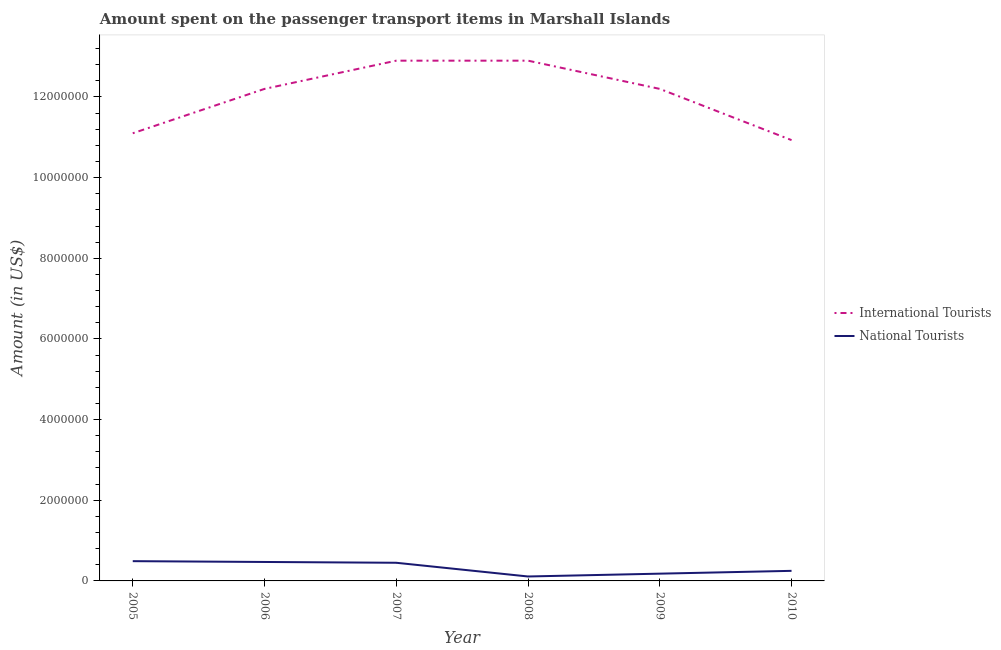How many different coloured lines are there?
Keep it short and to the point. 2. Does the line corresponding to amount spent on transport items of national tourists intersect with the line corresponding to amount spent on transport items of international tourists?
Ensure brevity in your answer.  No. Is the number of lines equal to the number of legend labels?
Provide a short and direct response. Yes. What is the amount spent on transport items of international tourists in 2005?
Your answer should be compact. 1.11e+07. Across all years, what is the maximum amount spent on transport items of national tourists?
Ensure brevity in your answer.  4.90e+05. Across all years, what is the minimum amount spent on transport items of national tourists?
Your answer should be compact. 1.10e+05. What is the total amount spent on transport items of national tourists in the graph?
Provide a succinct answer. 1.95e+06. What is the difference between the amount spent on transport items of international tourists in 2005 and that in 2006?
Your answer should be compact. -1.10e+06. What is the difference between the amount spent on transport items of international tourists in 2010 and the amount spent on transport items of national tourists in 2005?
Offer a very short reply. 1.04e+07. What is the average amount spent on transport items of international tourists per year?
Your response must be concise. 1.20e+07. In the year 2010, what is the difference between the amount spent on transport items of national tourists and amount spent on transport items of international tourists?
Make the answer very short. -1.07e+07. What is the ratio of the amount spent on transport items of international tourists in 2007 to that in 2008?
Provide a short and direct response. 1. Is the amount spent on transport items of international tourists in 2005 less than that in 2009?
Your answer should be compact. Yes. Is the difference between the amount spent on transport items of international tourists in 2006 and 2009 greater than the difference between the amount spent on transport items of national tourists in 2006 and 2009?
Offer a very short reply. No. What is the difference between the highest and the lowest amount spent on transport items of national tourists?
Make the answer very short. 3.80e+05. Is the sum of the amount spent on transport items of national tourists in 2006 and 2007 greater than the maximum amount spent on transport items of international tourists across all years?
Provide a succinct answer. No. Does the amount spent on transport items of international tourists monotonically increase over the years?
Your response must be concise. No. Is the amount spent on transport items of national tourists strictly less than the amount spent on transport items of international tourists over the years?
Make the answer very short. Yes. How many lines are there?
Provide a succinct answer. 2. How many years are there in the graph?
Offer a terse response. 6. Are the values on the major ticks of Y-axis written in scientific E-notation?
Your answer should be very brief. No. Does the graph contain grids?
Your answer should be very brief. No. Where does the legend appear in the graph?
Make the answer very short. Center right. What is the title of the graph?
Provide a short and direct response. Amount spent on the passenger transport items in Marshall Islands. Does "Taxes" appear as one of the legend labels in the graph?
Your response must be concise. No. What is the label or title of the Y-axis?
Your answer should be compact. Amount (in US$). What is the Amount (in US$) of International Tourists in 2005?
Your response must be concise. 1.11e+07. What is the Amount (in US$) in National Tourists in 2005?
Make the answer very short. 4.90e+05. What is the Amount (in US$) in International Tourists in 2006?
Offer a terse response. 1.22e+07. What is the Amount (in US$) in National Tourists in 2006?
Offer a very short reply. 4.70e+05. What is the Amount (in US$) of International Tourists in 2007?
Offer a very short reply. 1.29e+07. What is the Amount (in US$) in International Tourists in 2008?
Provide a succinct answer. 1.29e+07. What is the Amount (in US$) of National Tourists in 2008?
Provide a short and direct response. 1.10e+05. What is the Amount (in US$) in International Tourists in 2009?
Provide a succinct answer. 1.22e+07. What is the Amount (in US$) of International Tourists in 2010?
Offer a terse response. 1.09e+07. What is the Amount (in US$) in National Tourists in 2010?
Your answer should be very brief. 2.50e+05. Across all years, what is the maximum Amount (in US$) of International Tourists?
Offer a terse response. 1.29e+07. Across all years, what is the maximum Amount (in US$) of National Tourists?
Give a very brief answer. 4.90e+05. Across all years, what is the minimum Amount (in US$) of International Tourists?
Ensure brevity in your answer.  1.09e+07. Across all years, what is the minimum Amount (in US$) of National Tourists?
Your answer should be compact. 1.10e+05. What is the total Amount (in US$) in International Tourists in the graph?
Keep it short and to the point. 7.22e+07. What is the total Amount (in US$) in National Tourists in the graph?
Your answer should be very brief. 1.95e+06. What is the difference between the Amount (in US$) of International Tourists in 2005 and that in 2006?
Ensure brevity in your answer.  -1.10e+06. What is the difference between the Amount (in US$) of National Tourists in 2005 and that in 2006?
Ensure brevity in your answer.  2.00e+04. What is the difference between the Amount (in US$) of International Tourists in 2005 and that in 2007?
Offer a terse response. -1.80e+06. What is the difference between the Amount (in US$) of National Tourists in 2005 and that in 2007?
Your response must be concise. 4.00e+04. What is the difference between the Amount (in US$) of International Tourists in 2005 and that in 2008?
Give a very brief answer. -1.80e+06. What is the difference between the Amount (in US$) in National Tourists in 2005 and that in 2008?
Provide a succinct answer. 3.80e+05. What is the difference between the Amount (in US$) in International Tourists in 2005 and that in 2009?
Your answer should be compact. -1.10e+06. What is the difference between the Amount (in US$) in National Tourists in 2005 and that in 2009?
Offer a very short reply. 3.10e+05. What is the difference between the Amount (in US$) in International Tourists in 2005 and that in 2010?
Make the answer very short. 1.70e+05. What is the difference between the Amount (in US$) in National Tourists in 2005 and that in 2010?
Provide a succinct answer. 2.40e+05. What is the difference between the Amount (in US$) in International Tourists in 2006 and that in 2007?
Offer a terse response. -7.00e+05. What is the difference between the Amount (in US$) in National Tourists in 2006 and that in 2007?
Provide a succinct answer. 2.00e+04. What is the difference between the Amount (in US$) of International Tourists in 2006 and that in 2008?
Keep it short and to the point. -7.00e+05. What is the difference between the Amount (in US$) of International Tourists in 2006 and that in 2010?
Make the answer very short. 1.27e+06. What is the difference between the Amount (in US$) in International Tourists in 2007 and that in 2009?
Give a very brief answer. 7.00e+05. What is the difference between the Amount (in US$) in National Tourists in 2007 and that in 2009?
Offer a terse response. 2.70e+05. What is the difference between the Amount (in US$) of International Tourists in 2007 and that in 2010?
Offer a very short reply. 1.97e+06. What is the difference between the Amount (in US$) in International Tourists in 2008 and that in 2009?
Offer a terse response. 7.00e+05. What is the difference between the Amount (in US$) of International Tourists in 2008 and that in 2010?
Your response must be concise. 1.97e+06. What is the difference between the Amount (in US$) of International Tourists in 2009 and that in 2010?
Your response must be concise. 1.27e+06. What is the difference between the Amount (in US$) in International Tourists in 2005 and the Amount (in US$) in National Tourists in 2006?
Make the answer very short. 1.06e+07. What is the difference between the Amount (in US$) of International Tourists in 2005 and the Amount (in US$) of National Tourists in 2007?
Give a very brief answer. 1.06e+07. What is the difference between the Amount (in US$) of International Tourists in 2005 and the Amount (in US$) of National Tourists in 2008?
Offer a terse response. 1.10e+07. What is the difference between the Amount (in US$) of International Tourists in 2005 and the Amount (in US$) of National Tourists in 2009?
Keep it short and to the point. 1.09e+07. What is the difference between the Amount (in US$) in International Tourists in 2005 and the Amount (in US$) in National Tourists in 2010?
Provide a short and direct response. 1.08e+07. What is the difference between the Amount (in US$) of International Tourists in 2006 and the Amount (in US$) of National Tourists in 2007?
Make the answer very short. 1.18e+07. What is the difference between the Amount (in US$) in International Tourists in 2006 and the Amount (in US$) in National Tourists in 2008?
Provide a short and direct response. 1.21e+07. What is the difference between the Amount (in US$) of International Tourists in 2006 and the Amount (in US$) of National Tourists in 2009?
Provide a succinct answer. 1.20e+07. What is the difference between the Amount (in US$) in International Tourists in 2006 and the Amount (in US$) in National Tourists in 2010?
Your answer should be very brief. 1.20e+07. What is the difference between the Amount (in US$) of International Tourists in 2007 and the Amount (in US$) of National Tourists in 2008?
Ensure brevity in your answer.  1.28e+07. What is the difference between the Amount (in US$) in International Tourists in 2007 and the Amount (in US$) in National Tourists in 2009?
Keep it short and to the point. 1.27e+07. What is the difference between the Amount (in US$) of International Tourists in 2007 and the Amount (in US$) of National Tourists in 2010?
Your response must be concise. 1.26e+07. What is the difference between the Amount (in US$) of International Tourists in 2008 and the Amount (in US$) of National Tourists in 2009?
Your answer should be compact. 1.27e+07. What is the difference between the Amount (in US$) in International Tourists in 2008 and the Amount (in US$) in National Tourists in 2010?
Your response must be concise. 1.26e+07. What is the difference between the Amount (in US$) of International Tourists in 2009 and the Amount (in US$) of National Tourists in 2010?
Keep it short and to the point. 1.20e+07. What is the average Amount (in US$) of International Tourists per year?
Provide a short and direct response. 1.20e+07. What is the average Amount (in US$) of National Tourists per year?
Provide a succinct answer. 3.25e+05. In the year 2005, what is the difference between the Amount (in US$) of International Tourists and Amount (in US$) of National Tourists?
Your answer should be very brief. 1.06e+07. In the year 2006, what is the difference between the Amount (in US$) of International Tourists and Amount (in US$) of National Tourists?
Give a very brief answer. 1.17e+07. In the year 2007, what is the difference between the Amount (in US$) in International Tourists and Amount (in US$) in National Tourists?
Make the answer very short. 1.24e+07. In the year 2008, what is the difference between the Amount (in US$) of International Tourists and Amount (in US$) of National Tourists?
Your response must be concise. 1.28e+07. In the year 2009, what is the difference between the Amount (in US$) of International Tourists and Amount (in US$) of National Tourists?
Your answer should be compact. 1.20e+07. In the year 2010, what is the difference between the Amount (in US$) of International Tourists and Amount (in US$) of National Tourists?
Ensure brevity in your answer.  1.07e+07. What is the ratio of the Amount (in US$) in International Tourists in 2005 to that in 2006?
Provide a succinct answer. 0.91. What is the ratio of the Amount (in US$) of National Tourists in 2005 to that in 2006?
Your answer should be very brief. 1.04. What is the ratio of the Amount (in US$) of International Tourists in 2005 to that in 2007?
Ensure brevity in your answer.  0.86. What is the ratio of the Amount (in US$) in National Tourists in 2005 to that in 2007?
Give a very brief answer. 1.09. What is the ratio of the Amount (in US$) of International Tourists in 2005 to that in 2008?
Provide a succinct answer. 0.86. What is the ratio of the Amount (in US$) of National Tourists in 2005 to that in 2008?
Your answer should be compact. 4.45. What is the ratio of the Amount (in US$) of International Tourists in 2005 to that in 2009?
Provide a short and direct response. 0.91. What is the ratio of the Amount (in US$) of National Tourists in 2005 to that in 2009?
Keep it short and to the point. 2.72. What is the ratio of the Amount (in US$) in International Tourists in 2005 to that in 2010?
Provide a succinct answer. 1.02. What is the ratio of the Amount (in US$) in National Tourists in 2005 to that in 2010?
Ensure brevity in your answer.  1.96. What is the ratio of the Amount (in US$) in International Tourists in 2006 to that in 2007?
Offer a terse response. 0.95. What is the ratio of the Amount (in US$) of National Tourists in 2006 to that in 2007?
Your response must be concise. 1.04. What is the ratio of the Amount (in US$) in International Tourists in 2006 to that in 2008?
Offer a very short reply. 0.95. What is the ratio of the Amount (in US$) of National Tourists in 2006 to that in 2008?
Give a very brief answer. 4.27. What is the ratio of the Amount (in US$) of National Tourists in 2006 to that in 2009?
Your answer should be compact. 2.61. What is the ratio of the Amount (in US$) of International Tourists in 2006 to that in 2010?
Your answer should be compact. 1.12. What is the ratio of the Amount (in US$) in National Tourists in 2006 to that in 2010?
Ensure brevity in your answer.  1.88. What is the ratio of the Amount (in US$) in National Tourists in 2007 to that in 2008?
Keep it short and to the point. 4.09. What is the ratio of the Amount (in US$) of International Tourists in 2007 to that in 2009?
Give a very brief answer. 1.06. What is the ratio of the Amount (in US$) of International Tourists in 2007 to that in 2010?
Ensure brevity in your answer.  1.18. What is the ratio of the Amount (in US$) in International Tourists in 2008 to that in 2009?
Your answer should be compact. 1.06. What is the ratio of the Amount (in US$) in National Tourists in 2008 to that in 2009?
Give a very brief answer. 0.61. What is the ratio of the Amount (in US$) in International Tourists in 2008 to that in 2010?
Offer a very short reply. 1.18. What is the ratio of the Amount (in US$) in National Tourists in 2008 to that in 2010?
Keep it short and to the point. 0.44. What is the ratio of the Amount (in US$) of International Tourists in 2009 to that in 2010?
Provide a short and direct response. 1.12. What is the ratio of the Amount (in US$) of National Tourists in 2009 to that in 2010?
Provide a succinct answer. 0.72. What is the difference between the highest and the second highest Amount (in US$) of International Tourists?
Give a very brief answer. 0. What is the difference between the highest and the lowest Amount (in US$) in International Tourists?
Your answer should be very brief. 1.97e+06. 